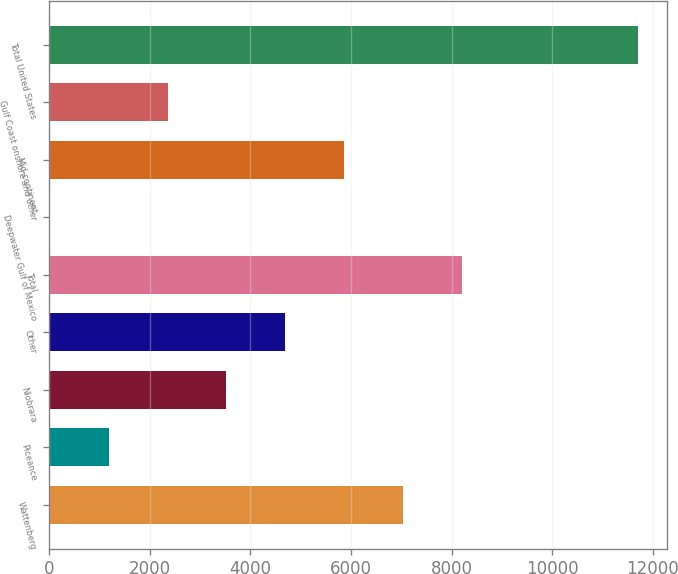<chart> <loc_0><loc_0><loc_500><loc_500><bar_chart><fcel>Wattenberg<fcel>Piceance<fcel>Niobrara<fcel>Other<fcel>Total<fcel>Deepwater Gulf of Mexico<fcel>Mid-continent<fcel>Gulf Coast onshore and other<fcel>Total United States<nl><fcel>7029.4<fcel>1182.4<fcel>3521.2<fcel>4690.6<fcel>8198.8<fcel>13<fcel>5860<fcel>2351.8<fcel>11707<nl></chart> 